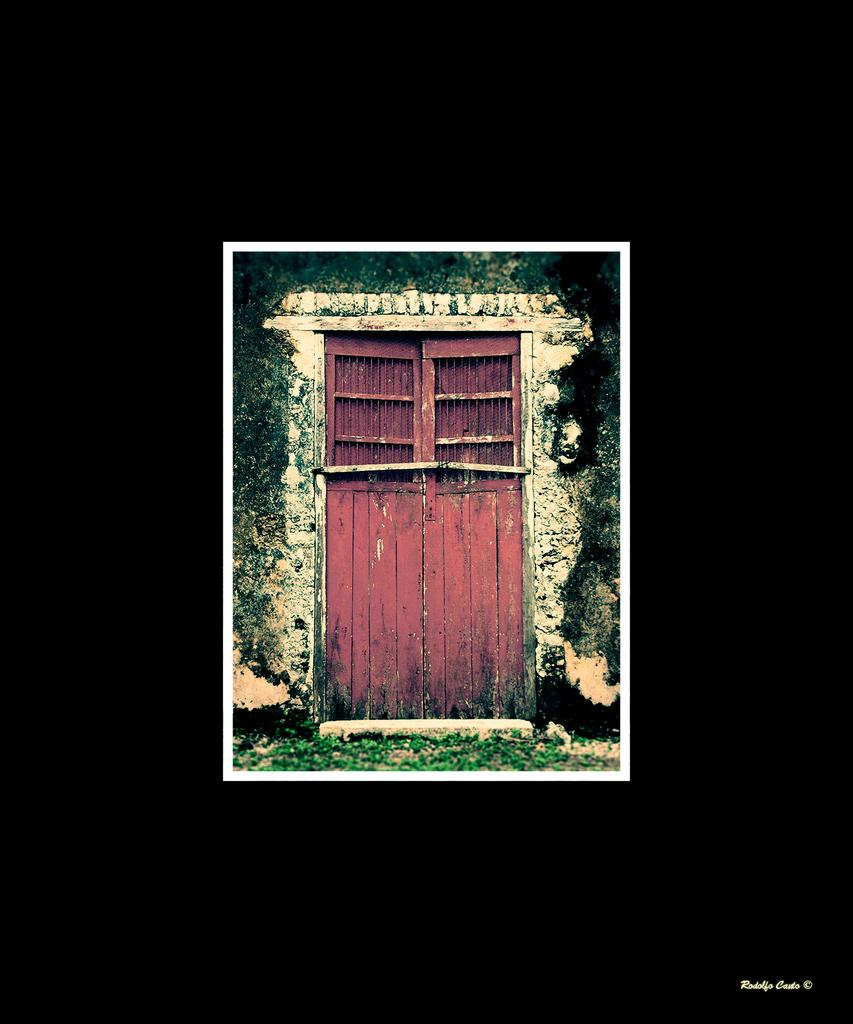What type of structure can be seen in the image? There is a house in the image. What is the primary feature of the house? There is a door in the image. What type of vegetation is present in the image? There is grass and creepers in the image. How many boys are playing with the flame in the image? There are no boys or flames present in the image. 